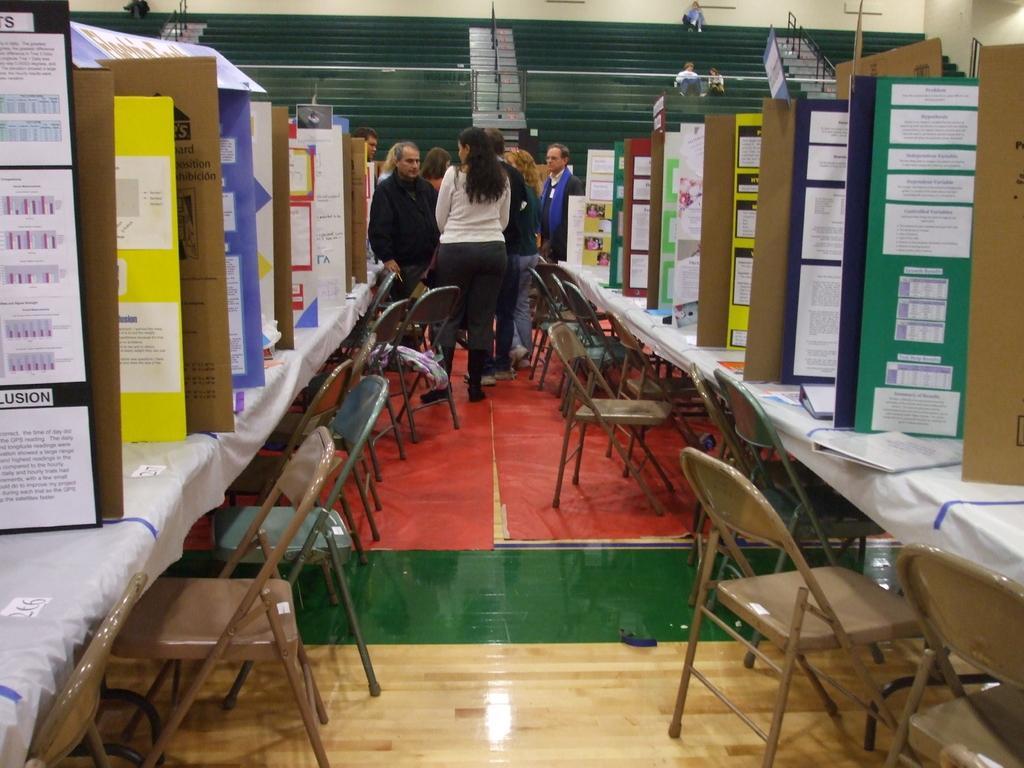Can you describe this image briefly? This is an inside view. Here I can see tables covered with white cloth. On this table there are some boards. In the background I can see few people are standing. On the top of the image I can see the stairs and few people are sitting on that. Beside this tables there are chairs arranged in an order. 